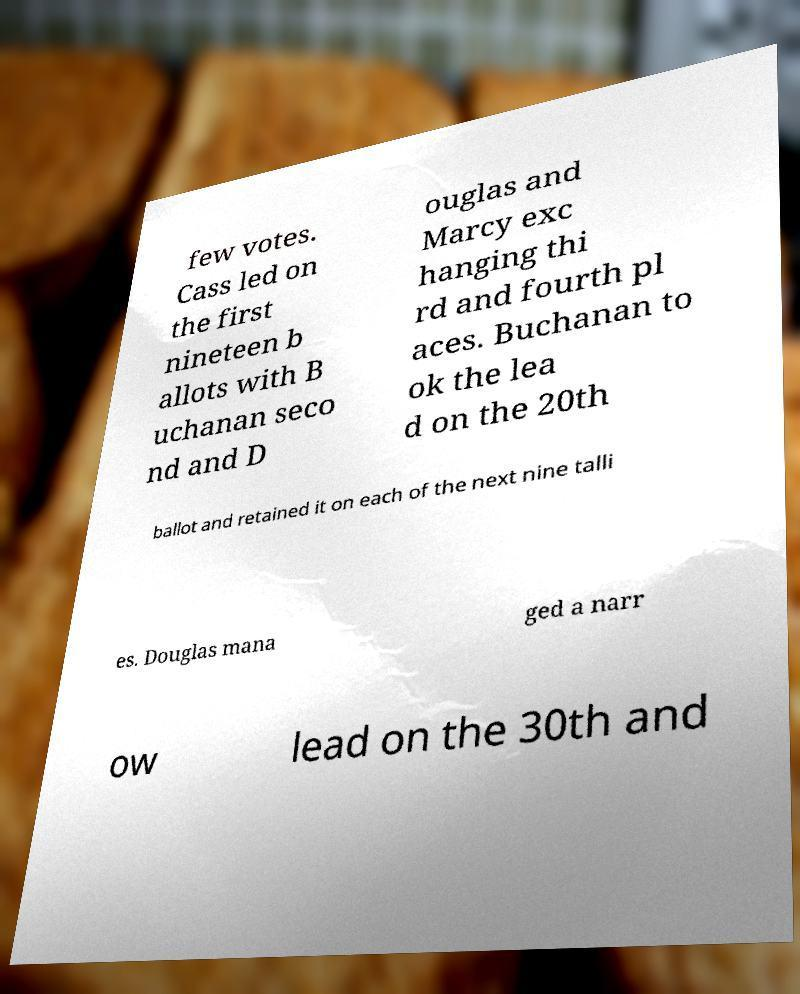There's text embedded in this image that I need extracted. Can you transcribe it verbatim? few votes. Cass led on the first nineteen b allots with B uchanan seco nd and D ouglas and Marcy exc hanging thi rd and fourth pl aces. Buchanan to ok the lea d on the 20th ballot and retained it on each of the next nine talli es. Douglas mana ged a narr ow lead on the 30th and 